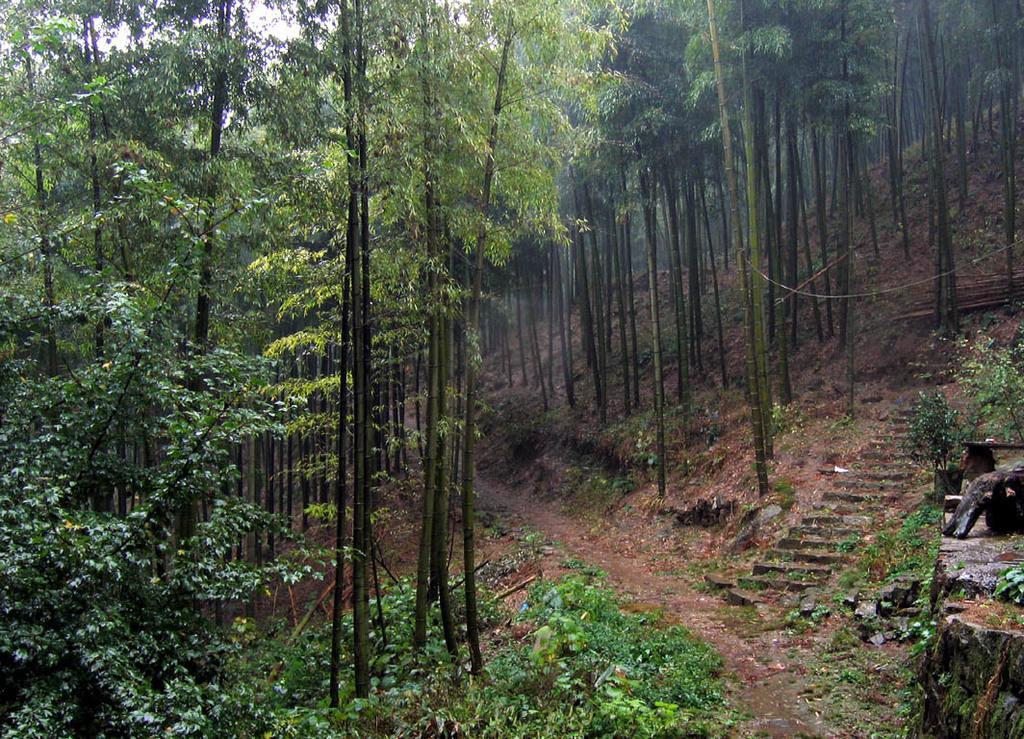Can you describe this image briefly? In this image we can see trees, plants, steps, path and grass on the ground. In the background we can see the sky. 